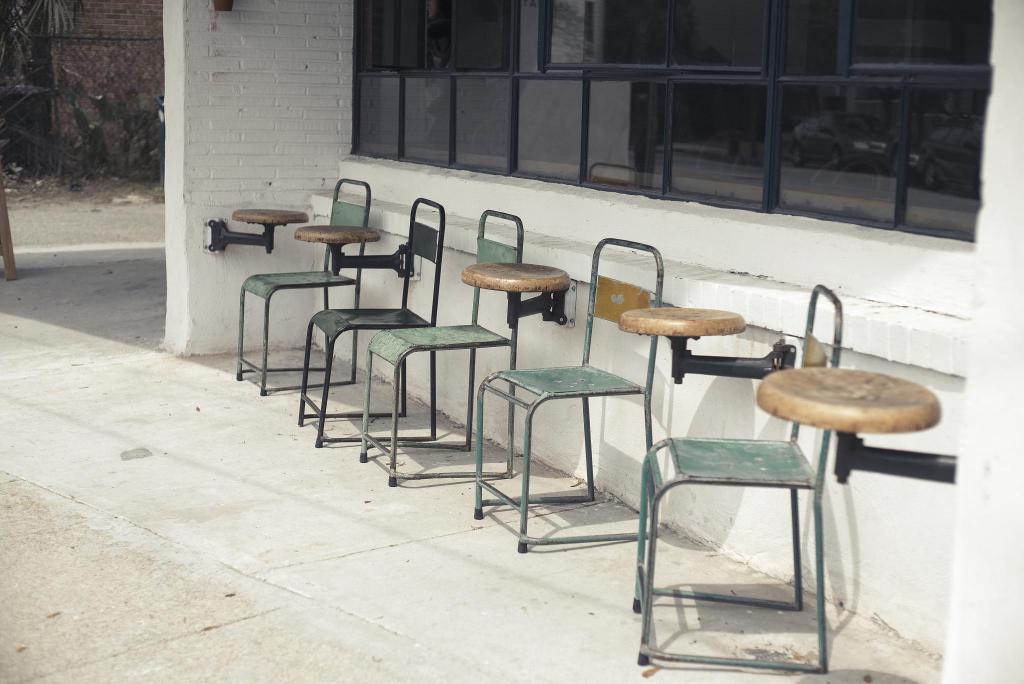In one or two sentences, can you explain what this image depicts? This picture might be taken from outside of the building and it is sunny. On the right side, we can see some tables and chairs. On the right side, we can see a glass window. In the middle of the image, we can see a wall. In the background, we can see a wood stick, trees and a brick wall. 